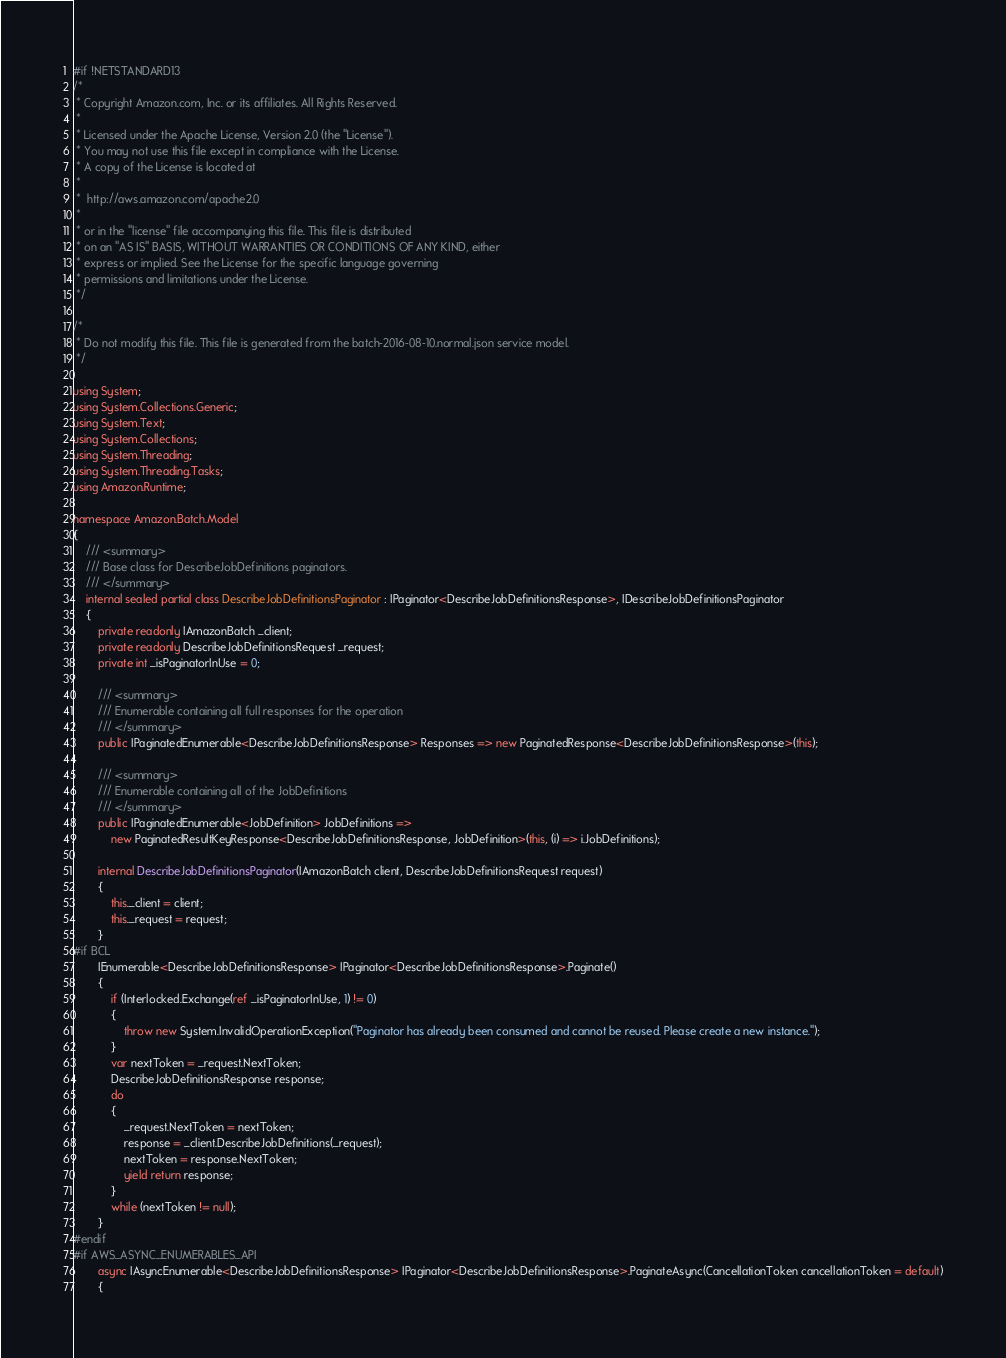<code> <loc_0><loc_0><loc_500><loc_500><_C#_>#if !NETSTANDARD13
/*
 * Copyright Amazon.com, Inc. or its affiliates. All Rights Reserved.
 * 
 * Licensed under the Apache License, Version 2.0 (the "License").
 * You may not use this file except in compliance with the License.
 * A copy of the License is located at
 * 
 *  http://aws.amazon.com/apache2.0
 * 
 * or in the "license" file accompanying this file. This file is distributed
 * on an "AS IS" BASIS, WITHOUT WARRANTIES OR CONDITIONS OF ANY KIND, either
 * express or implied. See the License for the specific language governing
 * permissions and limitations under the License.
 */

/*
 * Do not modify this file. This file is generated from the batch-2016-08-10.normal.json service model.
 */

using System;
using System.Collections.Generic;
using System.Text;
using System.Collections;
using System.Threading;
using System.Threading.Tasks;
using Amazon.Runtime;
 
namespace Amazon.Batch.Model
{
    /// <summary>
    /// Base class for DescribeJobDefinitions paginators.
    /// </summary>
    internal sealed partial class DescribeJobDefinitionsPaginator : IPaginator<DescribeJobDefinitionsResponse>, IDescribeJobDefinitionsPaginator
    {
        private readonly IAmazonBatch _client;
        private readonly DescribeJobDefinitionsRequest _request;
        private int _isPaginatorInUse = 0;
        
        /// <summary>
        /// Enumerable containing all full responses for the operation
        /// </summary>
        public IPaginatedEnumerable<DescribeJobDefinitionsResponse> Responses => new PaginatedResponse<DescribeJobDefinitionsResponse>(this);

        /// <summary>
        /// Enumerable containing all of the JobDefinitions
        /// </summary>
        public IPaginatedEnumerable<JobDefinition> JobDefinitions => 
            new PaginatedResultKeyResponse<DescribeJobDefinitionsResponse, JobDefinition>(this, (i) => i.JobDefinitions);

        internal DescribeJobDefinitionsPaginator(IAmazonBatch client, DescribeJobDefinitionsRequest request)
        {
            this._client = client;
            this._request = request;
        }
#if BCL
        IEnumerable<DescribeJobDefinitionsResponse> IPaginator<DescribeJobDefinitionsResponse>.Paginate()
        {
            if (Interlocked.Exchange(ref _isPaginatorInUse, 1) != 0)
            {
                throw new System.InvalidOperationException("Paginator has already been consumed and cannot be reused. Please create a new instance.");
            }
            var nextToken = _request.NextToken;
            DescribeJobDefinitionsResponse response;
            do
            {
                _request.NextToken = nextToken;
                response = _client.DescribeJobDefinitions(_request);
                nextToken = response.NextToken;
                yield return response;
            }
            while (nextToken != null);
        }
#endif
#if AWS_ASYNC_ENUMERABLES_API
        async IAsyncEnumerable<DescribeJobDefinitionsResponse> IPaginator<DescribeJobDefinitionsResponse>.PaginateAsync(CancellationToken cancellationToken = default)
        {</code> 